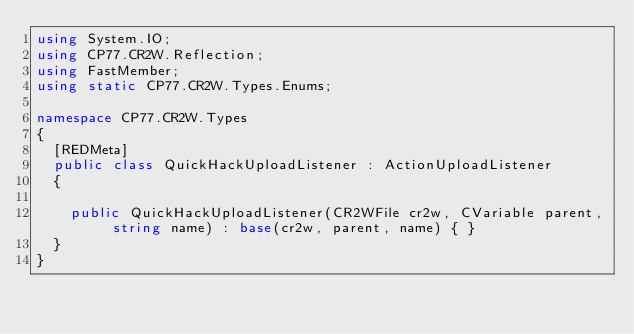<code> <loc_0><loc_0><loc_500><loc_500><_C#_>using System.IO;
using CP77.CR2W.Reflection;
using FastMember;
using static CP77.CR2W.Types.Enums;

namespace CP77.CR2W.Types
{
	[REDMeta]
	public class QuickHackUploadListener : ActionUploadListener
	{

		public QuickHackUploadListener(CR2WFile cr2w, CVariable parent, string name) : base(cr2w, parent, name) { }
	}
}
</code> 